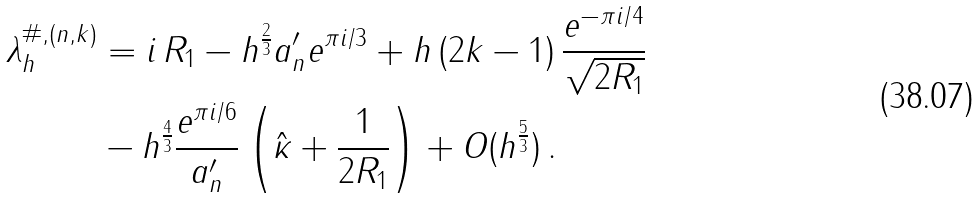Convert formula to latex. <formula><loc_0><loc_0><loc_500><loc_500>\lambda ^ { \# , ( n , k ) } _ { h } & = i \, R _ { 1 } - h ^ { \frac { 2 } { 3 } } a ^ { \prime } _ { n } e ^ { \pi i / 3 } + h \, ( 2 k - 1 ) \, \frac { e ^ { - \pi i / 4 } } { \sqrt { 2 R _ { 1 } } } \\ & - h ^ { \frac { 4 } { 3 } } \frac { e ^ { \pi i / 6 } } { a ^ { \prime } _ { n } } \left ( \hat { \kappa } + \frac { 1 } { 2 R _ { 1 } } \right ) + O ( h ^ { \frac { 5 } { 3 } } ) \, . \\</formula> 